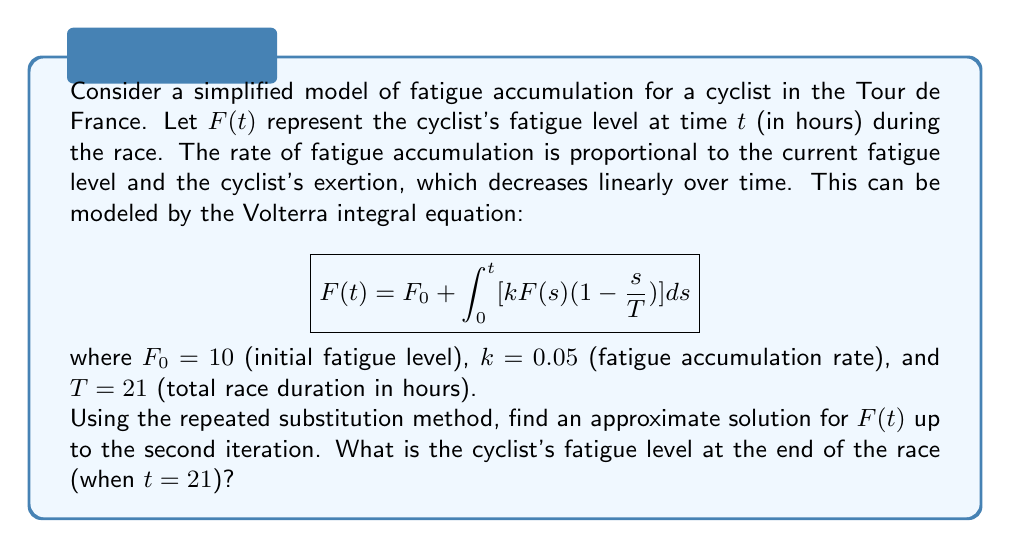Give your solution to this math problem. To solve this Volterra integral equation using the repeated substitution method, we'll follow these steps:

1) Start with the initial approximation $F_0(t) = F_0 = 10$

2) Substitute this into the integral equation to get the first approximation:

   $$F_1(t) = 10 + \int_0^t [0.05 \cdot 10 \cdot (1-\frac{s}{21})] ds$$

3) Solve this integral:
   
   $$F_1(t) = 10 + 0.5 \int_0^t (1-\frac{s}{21}) ds$$
   $$F_1(t) = 10 + 0.5 [s - \frac{s^2}{42}]_0^t$$
   $$F_1(t) = 10 + 0.5 (t - \frac{t^2}{42})$$

4) Now use $F_1(t)$ to find the second approximation:

   $$F_2(t) = 10 + \int_0^t [0.05 \cdot (10 + 0.5(s - \frac{s^2}{42})) \cdot (1-\frac{s}{21})] ds$$

5) Expand this:

   $$F_2(t) = 10 + \int_0^t [0.5 - \frac{0.5s}{21} + 0.025s - \frac{0.025s^2}{21} - \frac{0.025s^2}{84} + \frac{0.025s^3}{1764}] ds$$

6) Integrate term by term:

   $$F_2(t) = 10 + [0.5s - \frac{0.25s^2}{21} + \frac{0.025s^2}{2} - \frac{0.025s^3}{63} - \frac{0.025s^3}{252} + \frac{0.025s^4}{7056}]_0^t$$

7) Simplify:

   $$F_2(t) = 10 + 0.5t - \frac{0.25t^2}{21} + \frac{0.025t^2}{2} - \frac{0.025t^3}{63} - \frac{0.025t^3}{252} + \frac{0.025t^4}{7056}$$

8) To find the fatigue level at the end of the race, substitute $t = 21$:

   $$F_2(21) = 10 + 10.5 - 5.25 + 5.51625 - 3.675 - 0.91875 + 0.5468$$

9) Calculate the final result:

   $$F_2(21) \approx 16.72$$
Answer: 16.72 